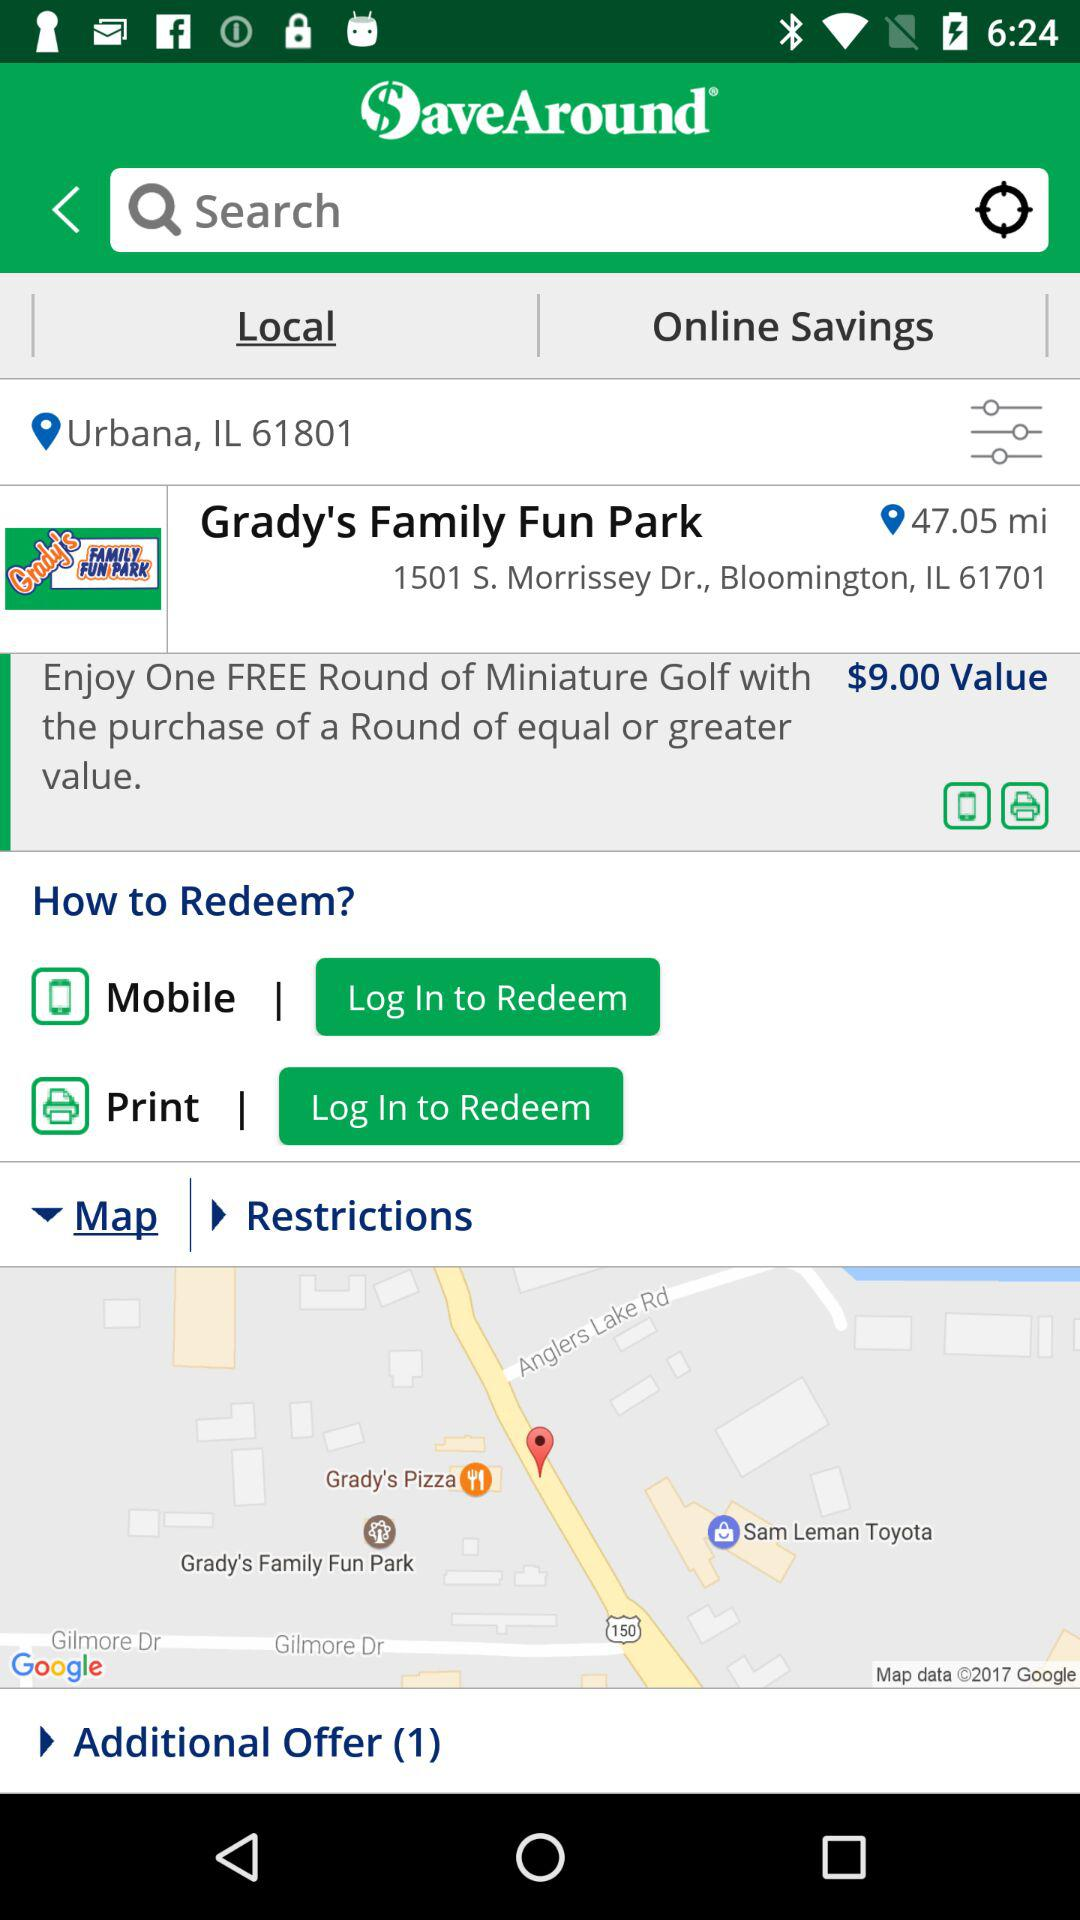What is the mentioned distance of the park? The mentioned distance is 47.05 miles. 